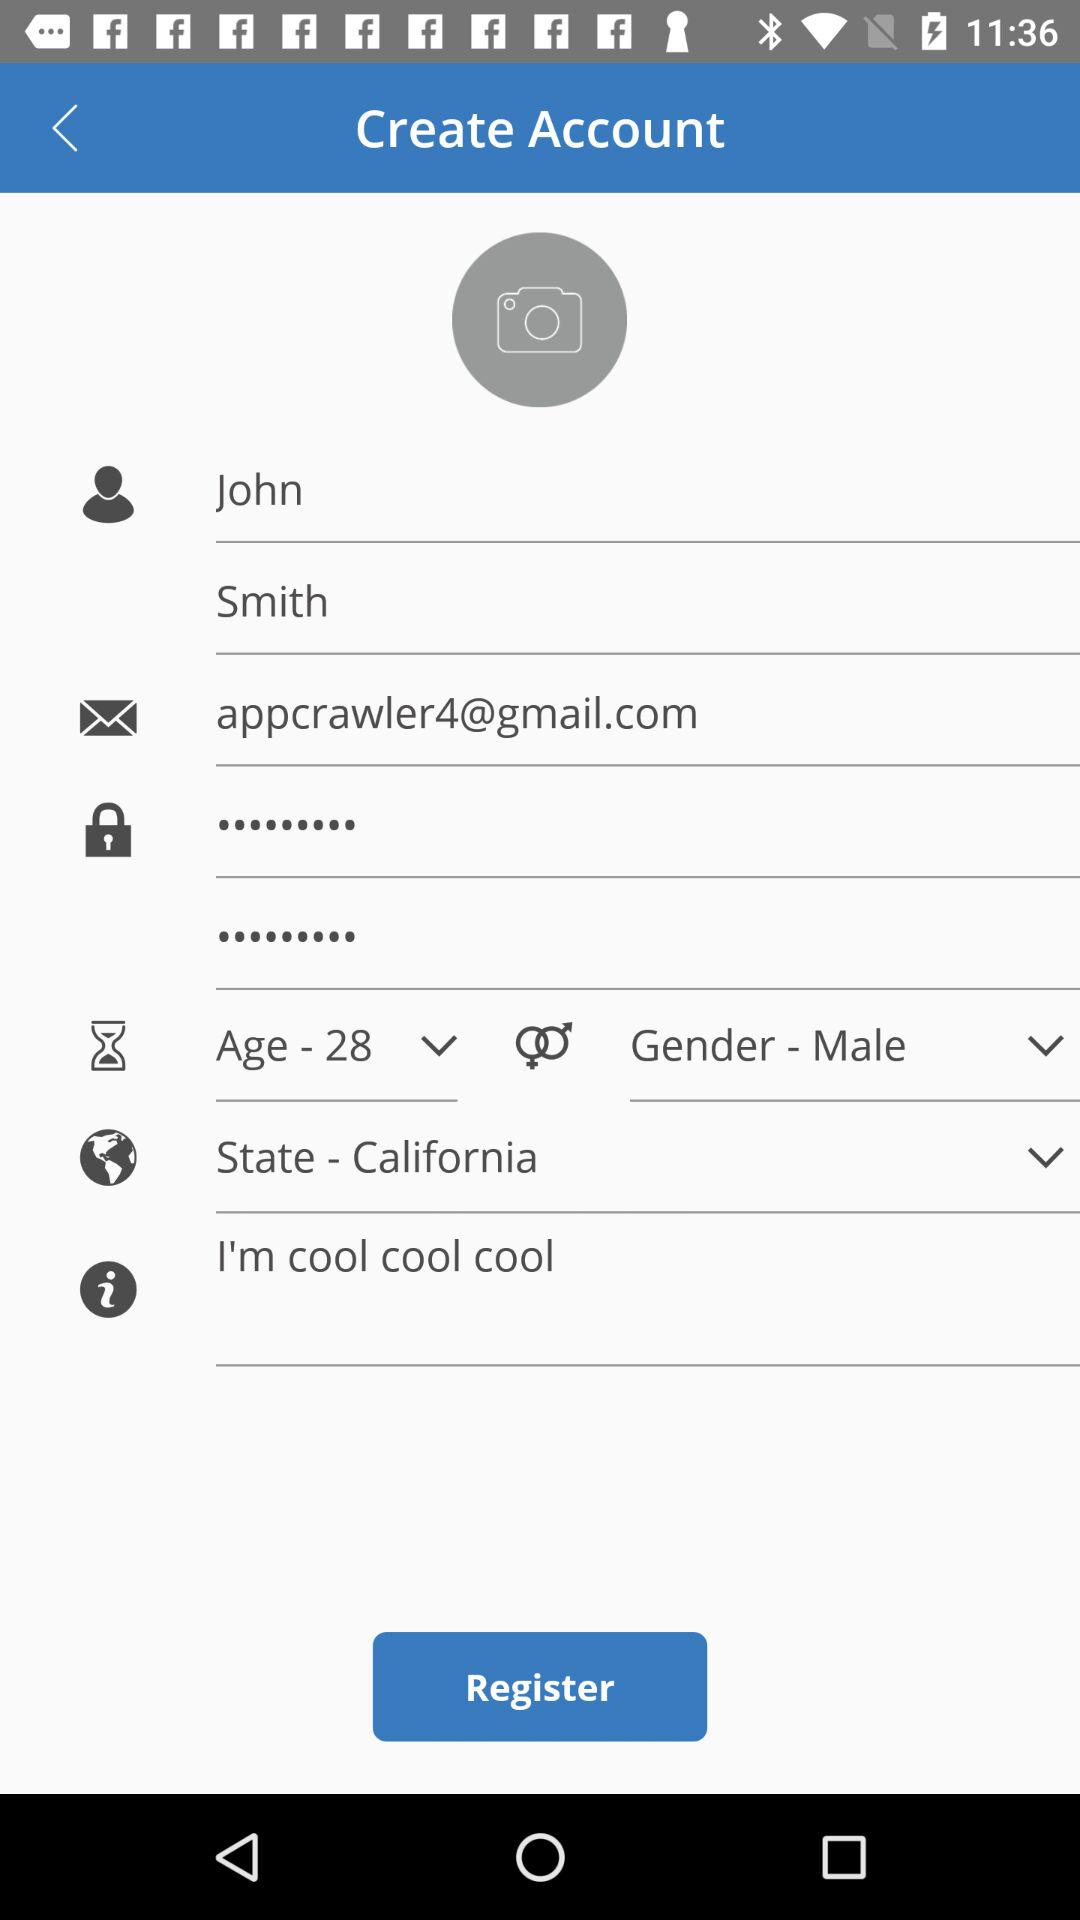What is the gender? The gender is male. 